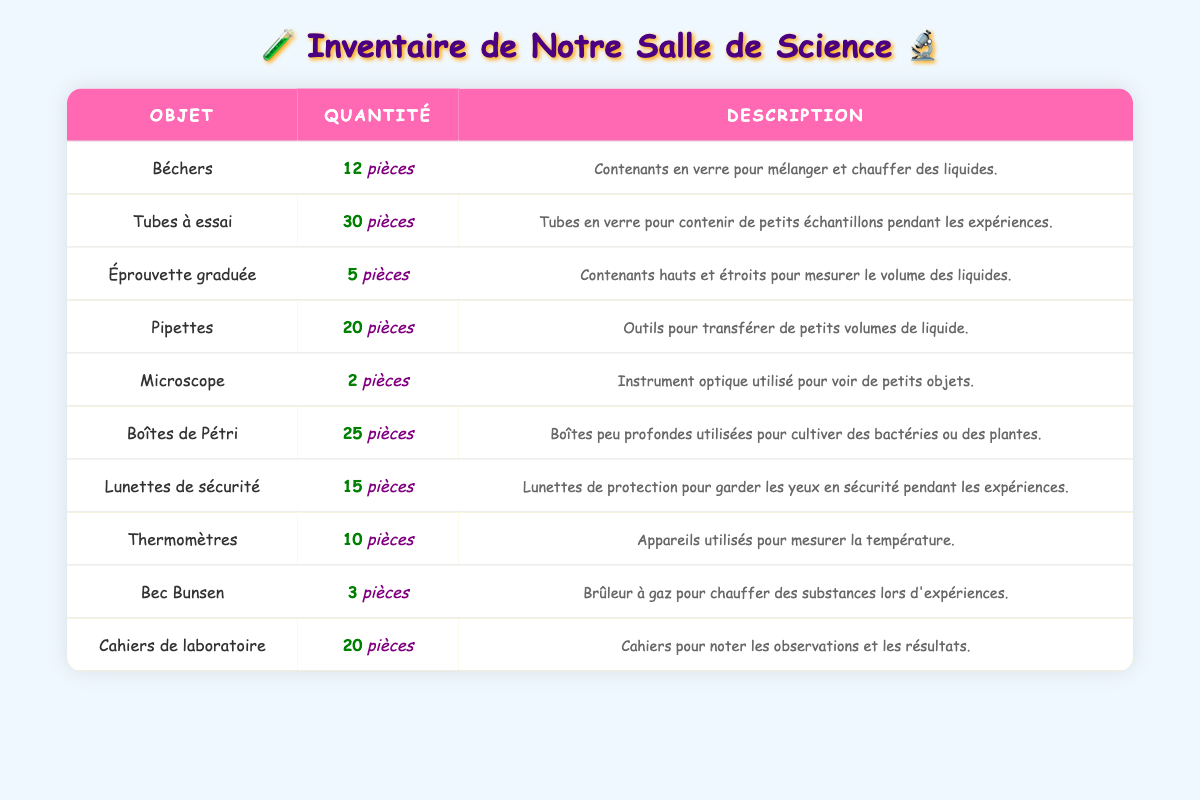What is the total quantity of beakers available? The table shows the quantity of beakers as 12. Therefore, the total quantity of beakers available is directly stated in the table.
Answer: 12 How many petri dishes do we have compared to thermometers? The table states there are 25 petri dishes and 10 thermometers. To find out how many more petri dishes there are than thermometers, we subtract: 25 - 10 = 15.
Answer: 15 Are there more test tubes or pipettes? The table states there are 30 test tubes and 20 pipettes. Since 30 is greater than 20, we can conclude that there are more test tubes than pipettes.
Answer: Yes What is the quantity of safety goggles? The table lists the quantity of safety goggles as 15 pieces. Therefore, the answer can be found directly in the table.
Answer: 15 If you add the quantities of microscopes and Bunsen burners, what do you get? The table shows there are 2 microscopes and 3 Bunsen burners. Adding these together gives: 2 + 3 = 5. Therefore, the total is 5.
Answer: 5 Is the description for thermometers listed in the inventory table? Yes, the table includes a description for thermometers, stating that they are devices used to measure temperature. Thus, the answer is clear according to what is presented in the table.
Answer: Yes What is the difference in quantity between beakers and graduated cylinders? The table shows 12 beakers and 5 graduated cylinders. To find the difference, we subtract: 12 - 5 = 7. Therefore, there are 7 more beakers than graduated cylinders.
Answer: 7 If you count all the lab notebooks and safety goggles together, how many do you have? The table shows there are 20 lab notebooks and 15 safety goggles. Adding these together gives: 20 + 15 = 35. Thus, the total is 35.
Answer: 35 Which item has the least quantity in the inventory? The table shows that microscopes have the least quantity with 2 pieces, which is less than all the other items listed. Therefore, this item has the smallest quantity.
Answer: Microscopes 